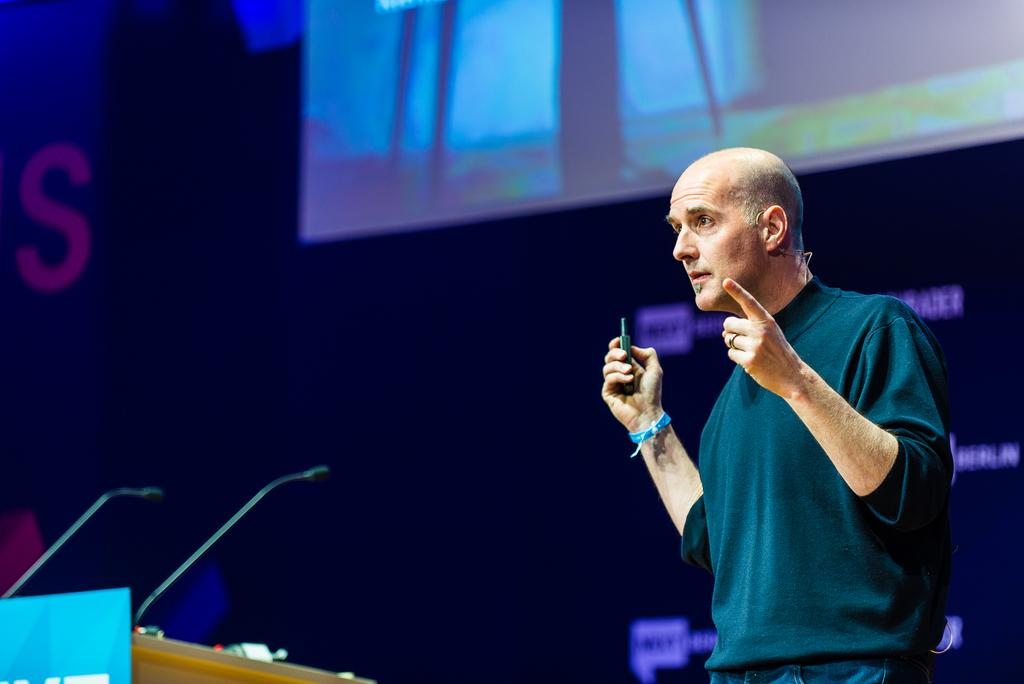Who or what is present in the image? There is a person in the image. What is the person holding in the image? The person is holding a remote. What is in front of the person in the image? There is a podium in front of the person. How many microphones are visible in the image? There are two microphones in the image. What is the purpose of the screen in the image? The purpose of the screen in the image is not specified, but it could be used for displaying information or visuals. What type of sleet can be seen falling on the person in the image? There is no sleet present in the image; it is an indoor setting. How does the acoustics of the room affect the person's speech in the image? The provided facts do not mention any information about the acoustics of the room, so it cannot be determined how it affects the person's speech. 